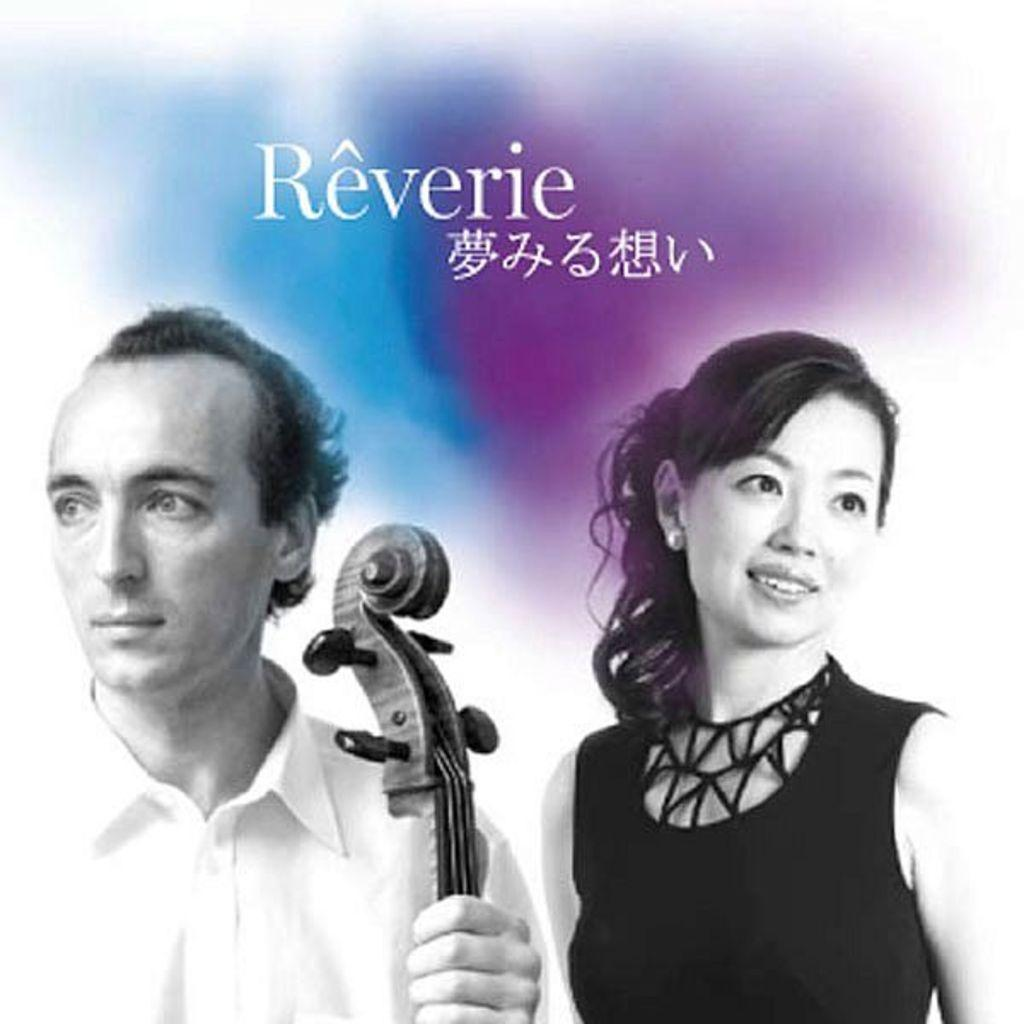Who is present on the left side of the image? There is a man on the left side of the image. What is the man wearing in the image? The man is wearing a white shirt in the image. Who is present on the right side of the image? There is a girl on the right side of the image. What is the girl wearing in the image? The girl is wearing a black dress in the image. What type of operation is being performed on the rice in the image? There is no rice or operation present in the image. What color is the girl's hair in the image? The provided facts do not mention the color of the girl's hair, so it cannot be determined from the image. 